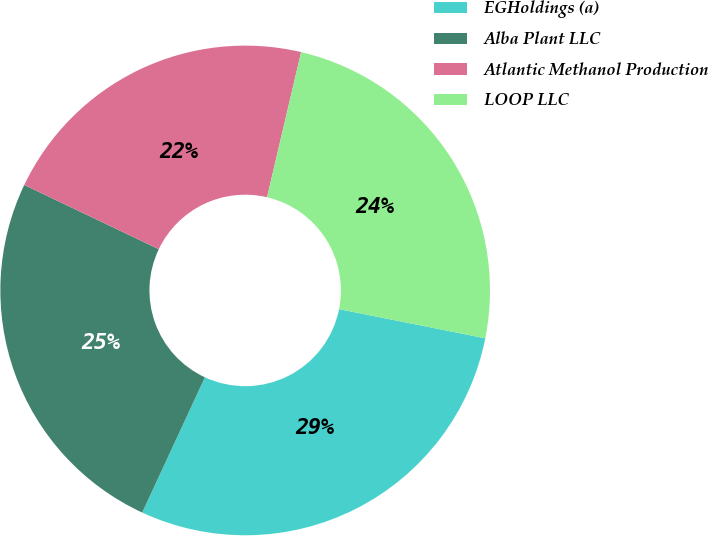Convert chart to OTSL. <chart><loc_0><loc_0><loc_500><loc_500><pie_chart><fcel>EGHoldings (a)<fcel>Alba Plant LLC<fcel>Atlantic Methanol Production<fcel>LOOP LLC<nl><fcel>28.78%<fcel>25.18%<fcel>21.58%<fcel>24.46%<nl></chart> 